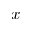Convert formula to latex. <formula><loc_0><loc_0><loc_500><loc_500>x</formula> 